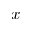Convert formula to latex. <formula><loc_0><loc_0><loc_500><loc_500>x</formula> 